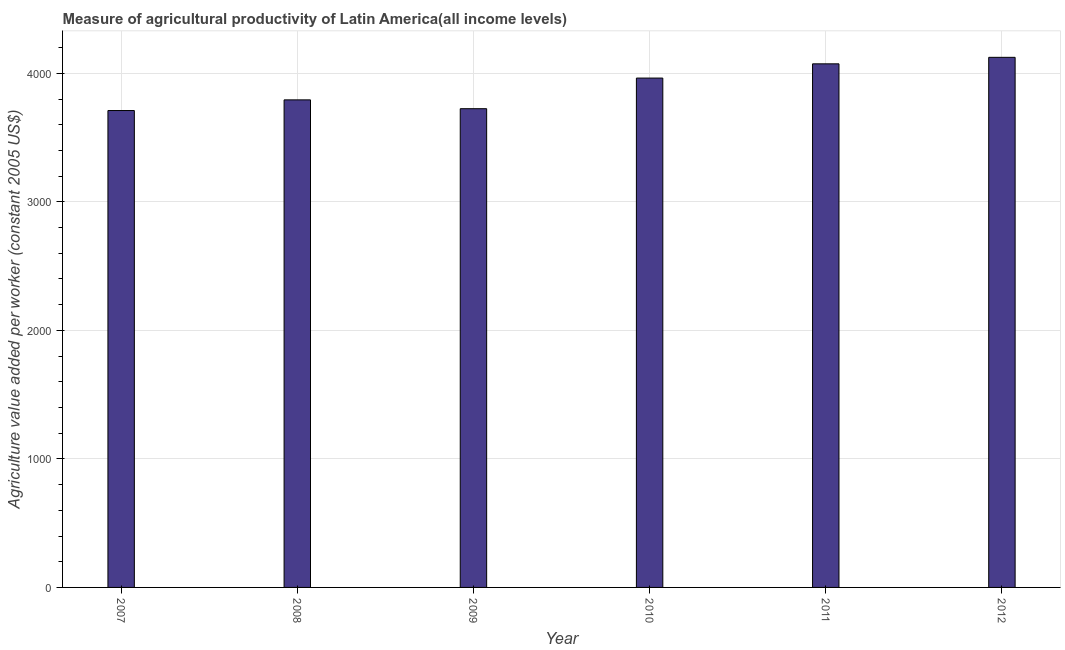Does the graph contain any zero values?
Provide a short and direct response. No. What is the title of the graph?
Make the answer very short. Measure of agricultural productivity of Latin America(all income levels). What is the label or title of the Y-axis?
Offer a terse response. Agriculture value added per worker (constant 2005 US$). What is the agriculture value added per worker in 2007?
Your response must be concise. 3710.26. Across all years, what is the maximum agriculture value added per worker?
Ensure brevity in your answer.  4124.23. Across all years, what is the minimum agriculture value added per worker?
Keep it short and to the point. 3710.26. What is the sum of the agriculture value added per worker?
Offer a terse response. 2.34e+04. What is the difference between the agriculture value added per worker in 2008 and 2010?
Keep it short and to the point. -169.6. What is the average agriculture value added per worker per year?
Offer a very short reply. 3898.12. What is the median agriculture value added per worker?
Your response must be concise. 3878.02. Do a majority of the years between 2011 and 2007 (inclusive) have agriculture value added per worker greater than 1600 US$?
Your response must be concise. Yes. What is the ratio of the agriculture value added per worker in 2009 to that in 2011?
Provide a short and direct response. 0.91. Is the difference between the agriculture value added per worker in 2010 and 2011 greater than the difference between any two years?
Offer a terse response. No. What is the difference between the highest and the second highest agriculture value added per worker?
Provide a succinct answer. 50.6. Is the sum of the agriculture value added per worker in 2008 and 2012 greater than the maximum agriculture value added per worker across all years?
Give a very brief answer. Yes. What is the difference between the highest and the lowest agriculture value added per worker?
Give a very brief answer. 413.97. In how many years, is the agriculture value added per worker greater than the average agriculture value added per worker taken over all years?
Make the answer very short. 3. How many bars are there?
Give a very brief answer. 6. Are all the bars in the graph horizontal?
Your answer should be compact. No. What is the difference between two consecutive major ticks on the Y-axis?
Offer a very short reply. 1000. What is the Agriculture value added per worker (constant 2005 US$) of 2007?
Keep it short and to the point. 3710.26. What is the Agriculture value added per worker (constant 2005 US$) in 2008?
Your answer should be compact. 3793.22. What is the Agriculture value added per worker (constant 2005 US$) of 2009?
Your answer should be very brief. 3724.58. What is the Agriculture value added per worker (constant 2005 US$) in 2010?
Keep it short and to the point. 3962.82. What is the Agriculture value added per worker (constant 2005 US$) of 2011?
Ensure brevity in your answer.  4073.63. What is the Agriculture value added per worker (constant 2005 US$) of 2012?
Provide a short and direct response. 4124.23. What is the difference between the Agriculture value added per worker (constant 2005 US$) in 2007 and 2008?
Give a very brief answer. -82.96. What is the difference between the Agriculture value added per worker (constant 2005 US$) in 2007 and 2009?
Make the answer very short. -14.33. What is the difference between the Agriculture value added per worker (constant 2005 US$) in 2007 and 2010?
Give a very brief answer. -252.56. What is the difference between the Agriculture value added per worker (constant 2005 US$) in 2007 and 2011?
Your answer should be very brief. -363.37. What is the difference between the Agriculture value added per worker (constant 2005 US$) in 2007 and 2012?
Give a very brief answer. -413.97. What is the difference between the Agriculture value added per worker (constant 2005 US$) in 2008 and 2009?
Provide a succinct answer. 68.64. What is the difference between the Agriculture value added per worker (constant 2005 US$) in 2008 and 2010?
Ensure brevity in your answer.  -169.6. What is the difference between the Agriculture value added per worker (constant 2005 US$) in 2008 and 2011?
Keep it short and to the point. -280.41. What is the difference between the Agriculture value added per worker (constant 2005 US$) in 2008 and 2012?
Keep it short and to the point. -331.01. What is the difference between the Agriculture value added per worker (constant 2005 US$) in 2009 and 2010?
Give a very brief answer. -238.23. What is the difference between the Agriculture value added per worker (constant 2005 US$) in 2009 and 2011?
Provide a short and direct response. -349.04. What is the difference between the Agriculture value added per worker (constant 2005 US$) in 2009 and 2012?
Provide a short and direct response. -399.64. What is the difference between the Agriculture value added per worker (constant 2005 US$) in 2010 and 2011?
Offer a very short reply. -110.81. What is the difference between the Agriculture value added per worker (constant 2005 US$) in 2010 and 2012?
Give a very brief answer. -161.41. What is the difference between the Agriculture value added per worker (constant 2005 US$) in 2011 and 2012?
Make the answer very short. -50.6. What is the ratio of the Agriculture value added per worker (constant 2005 US$) in 2007 to that in 2008?
Give a very brief answer. 0.98. What is the ratio of the Agriculture value added per worker (constant 2005 US$) in 2007 to that in 2009?
Give a very brief answer. 1. What is the ratio of the Agriculture value added per worker (constant 2005 US$) in 2007 to that in 2010?
Your answer should be compact. 0.94. What is the ratio of the Agriculture value added per worker (constant 2005 US$) in 2007 to that in 2011?
Provide a short and direct response. 0.91. What is the ratio of the Agriculture value added per worker (constant 2005 US$) in 2007 to that in 2012?
Provide a succinct answer. 0.9. What is the ratio of the Agriculture value added per worker (constant 2005 US$) in 2008 to that in 2011?
Offer a terse response. 0.93. What is the ratio of the Agriculture value added per worker (constant 2005 US$) in 2008 to that in 2012?
Give a very brief answer. 0.92. What is the ratio of the Agriculture value added per worker (constant 2005 US$) in 2009 to that in 2010?
Your response must be concise. 0.94. What is the ratio of the Agriculture value added per worker (constant 2005 US$) in 2009 to that in 2011?
Provide a short and direct response. 0.91. What is the ratio of the Agriculture value added per worker (constant 2005 US$) in 2009 to that in 2012?
Offer a very short reply. 0.9. 